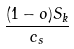<formula> <loc_0><loc_0><loc_500><loc_500>\frac { ( 1 - o ) S _ { k } } { c _ { s } }</formula> 